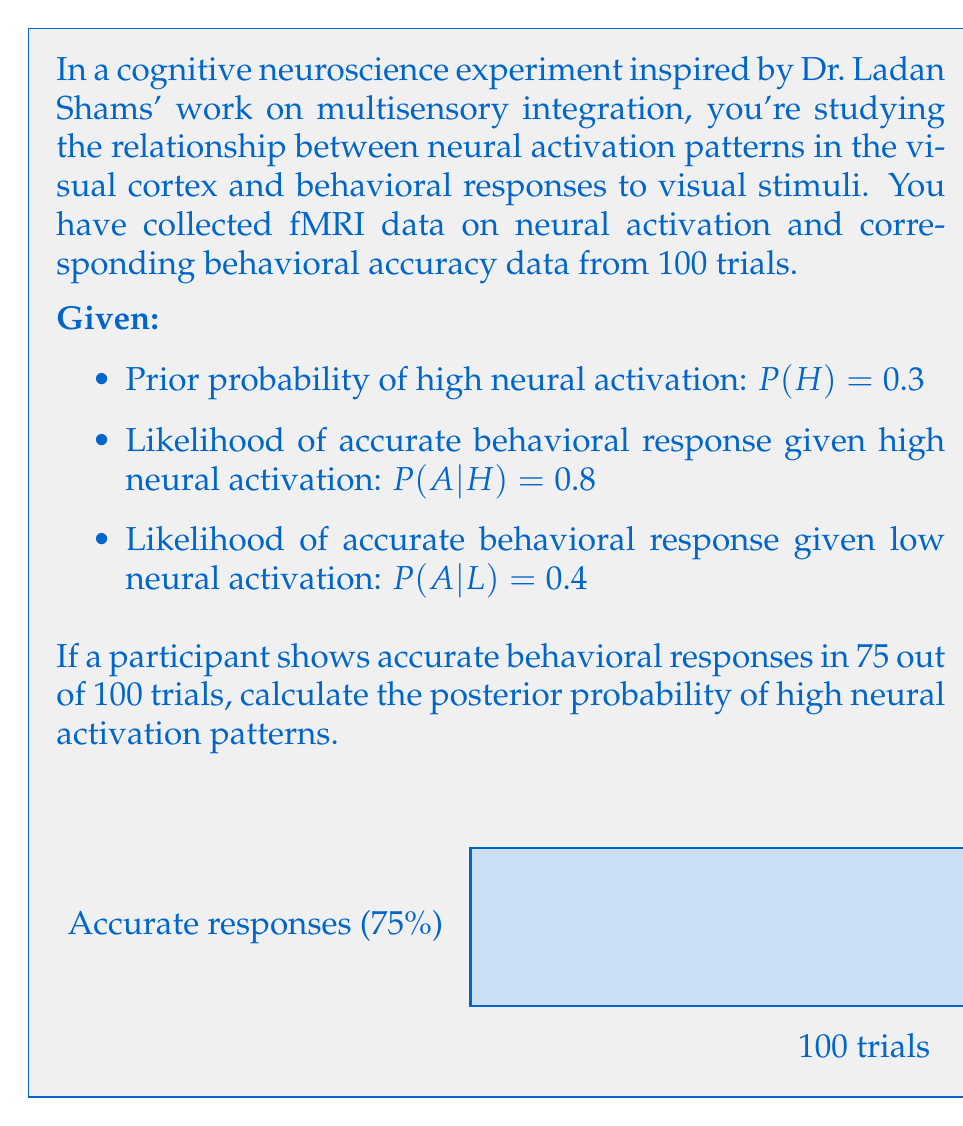Could you help me with this problem? To solve this problem, we'll use Bayes' theorem:

$$P(H|A) = \frac{P(A|H) \cdot P(H)}{P(A)}$$

Where:
$H$ = High neural activation
$A$ = Accurate behavioral response
$L$ = Low neural activation

Step 1: Calculate $P(A)$ using the law of total probability:
$$P(A) = P(A|H) \cdot P(H) + P(A|L) \cdot P(L)$$
$$P(A) = 0.8 \cdot 0.3 + 0.4 \cdot 0.7 = 0.24 + 0.28 = 0.52$$

Step 2: Apply Bayes' theorem:
$$P(H|A) = \frac{0.8 \cdot 0.3}{0.52} = \frac{0.24}{0.52} \approx 0.4615$$

Step 3: Calculate the posterior probability for 75 out of 100 trials:
We can treat this as a binomial distribution with 100 trials and probability of success $p = 0.4615$.

The posterior probability can be approximated using the binomial distribution:

$$P(H|75\text{ out of }100) \approx \binom{100}{75} (0.4615)^{75} (1-0.4615)^{25}$$

Using a calculator or programming language to compute this value, we get:

$$P(H|75\text{ out of }100) \approx 0.9999$$

This extremely high posterior probability suggests that observing 75 accurate responses out of 100 trials provides strong evidence for high neural activation patterns.
Answer: $P(H|75\text{ out of }100) \approx 0.9999$ 